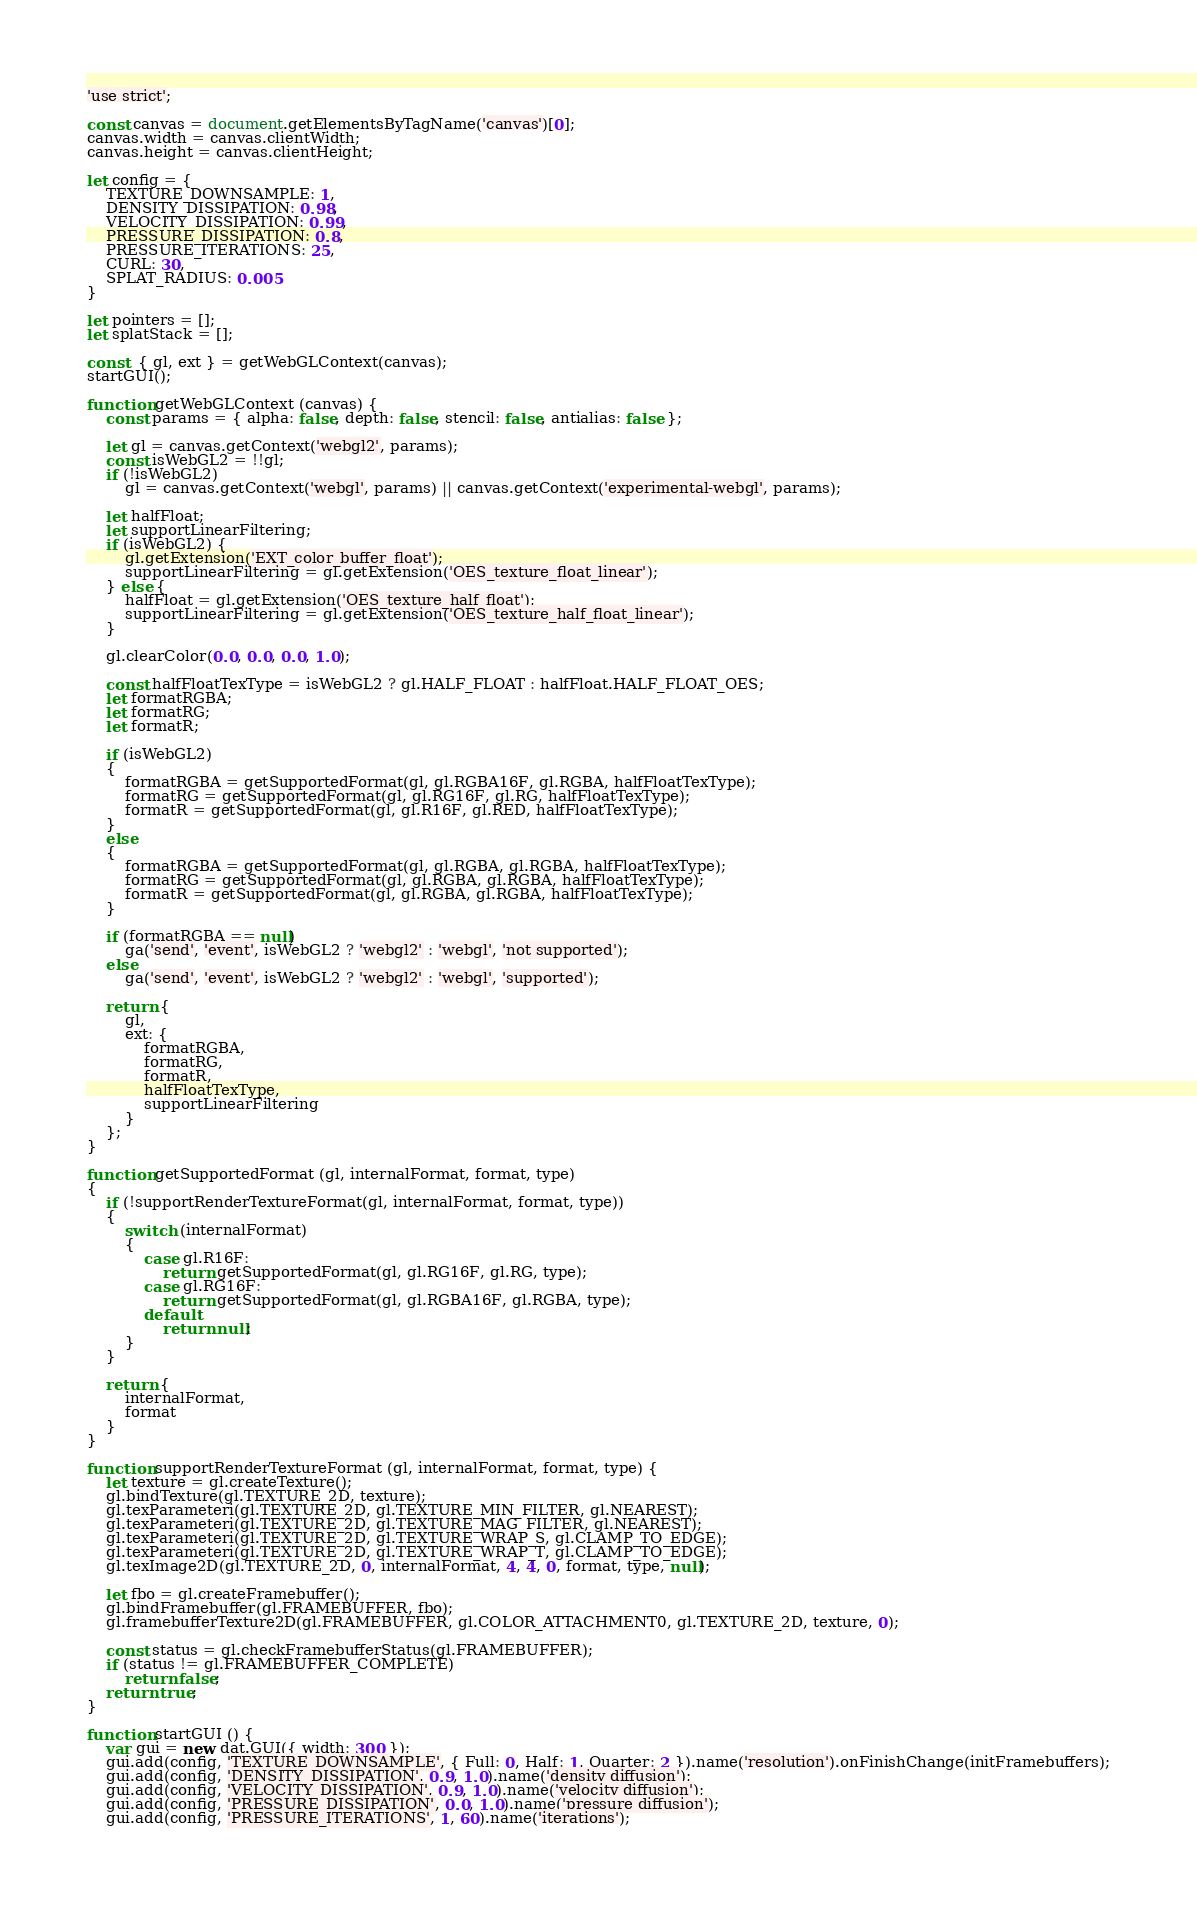<code> <loc_0><loc_0><loc_500><loc_500><_JavaScript_>'use strict';

const canvas = document.getElementsByTagName('canvas')[0];
canvas.width = canvas.clientWidth;
canvas.height = canvas.clientHeight;

let config = {
    TEXTURE_DOWNSAMPLE: 1,
    DENSITY_DISSIPATION: 0.98,
    VELOCITY_DISSIPATION: 0.99,
    PRESSURE_DISSIPATION: 0.8,
    PRESSURE_ITERATIONS: 25,
    CURL: 30,
    SPLAT_RADIUS: 0.005
}

let pointers = [];
let splatStack = [];

const  { gl, ext } = getWebGLContext(canvas);
startGUI();

function getWebGLContext (canvas) {
    const params = { alpha: false, depth: false, stencil: false, antialias: false };

    let gl = canvas.getContext('webgl2', params);
    const isWebGL2 = !!gl;
    if (!isWebGL2)
        gl = canvas.getContext('webgl', params) || canvas.getContext('experimental-webgl', params);

    let halfFloat;
    let supportLinearFiltering;
    if (isWebGL2) {
        gl.getExtension('EXT_color_buffer_float');
        supportLinearFiltering = gl.getExtension('OES_texture_float_linear');
    } else {
        halfFloat = gl.getExtension('OES_texture_half_float');
        supportLinearFiltering = gl.getExtension('OES_texture_half_float_linear');
    }

    gl.clearColor(0.0, 0.0, 0.0, 1.0);

    const halfFloatTexType = isWebGL2 ? gl.HALF_FLOAT : halfFloat.HALF_FLOAT_OES;
    let formatRGBA;
    let formatRG;
    let formatR;

    if (isWebGL2)
    {
        formatRGBA = getSupportedFormat(gl, gl.RGBA16F, gl.RGBA, halfFloatTexType);
        formatRG = getSupportedFormat(gl, gl.RG16F, gl.RG, halfFloatTexType);
        formatR = getSupportedFormat(gl, gl.R16F, gl.RED, halfFloatTexType);
    }
    else
    {
        formatRGBA = getSupportedFormat(gl, gl.RGBA, gl.RGBA, halfFloatTexType);
        formatRG = getSupportedFormat(gl, gl.RGBA, gl.RGBA, halfFloatTexType);
        formatR = getSupportedFormat(gl, gl.RGBA, gl.RGBA, halfFloatTexType);
    }

    if (formatRGBA == null)
        ga('send', 'event', isWebGL2 ? 'webgl2' : 'webgl', 'not supported');
    else
        ga('send', 'event', isWebGL2 ? 'webgl2' : 'webgl', 'supported');

    return {
        gl,
        ext: {
            formatRGBA,
            formatRG,
            formatR,
            halfFloatTexType,
            supportLinearFiltering
        }
    };
}

function getSupportedFormat (gl, internalFormat, format, type)
{
    if (!supportRenderTextureFormat(gl, internalFormat, format, type))
    {
        switch (internalFormat)
        {
            case gl.R16F:
                return getSupportedFormat(gl, gl.RG16F, gl.RG, type);
            case gl.RG16F:
                return getSupportedFormat(gl, gl.RGBA16F, gl.RGBA, type);
            default:
                return null;
        }
    }

    return {
        internalFormat,
        format
    }
}

function supportRenderTextureFormat (gl, internalFormat, format, type) {
    let texture = gl.createTexture();
    gl.bindTexture(gl.TEXTURE_2D, texture);
    gl.texParameteri(gl.TEXTURE_2D, gl.TEXTURE_MIN_FILTER, gl.NEAREST);
    gl.texParameteri(gl.TEXTURE_2D, gl.TEXTURE_MAG_FILTER, gl.NEAREST);
    gl.texParameteri(gl.TEXTURE_2D, gl.TEXTURE_WRAP_S, gl.CLAMP_TO_EDGE);
    gl.texParameteri(gl.TEXTURE_2D, gl.TEXTURE_WRAP_T, gl.CLAMP_TO_EDGE);
    gl.texImage2D(gl.TEXTURE_2D, 0, internalFormat, 4, 4, 0, format, type, null);

    let fbo = gl.createFramebuffer();
    gl.bindFramebuffer(gl.FRAMEBUFFER, fbo);
    gl.framebufferTexture2D(gl.FRAMEBUFFER, gl.COLOR_ATTACHMENT0, gl.TEXTURE_2D, texture, 0);

    const status = gl.checkFramebufferStatus(gl.FRAMEBUFFER);
    if (status != gl.FRAMEBUFFER_COMPLETE)
        return false;
    return true;
}

function startGUI () {
    var gui = new dat.GUI({ width: 300 });
    gui.add(config, 'TEXTURE_DOWNSAMPLE', { Full: 0, Half: 1, Quarter: 2 }).name('resolution').onFinishChange(initFramebuffers);
    gui.add(config, 'DENSITY_DISSIPATION', 0.9, 1.0).name('density diffusion');
    gui.add(config, 'VELOCITY_DISSIPATION', 0.9, 1.0).name('velocity diffusion');
    gui.add(config, 'PRESSURE_DISSIPATION', 0.0, 1.0).name('pressure diffusion');
    gui.add(config, 'PRESSURE_ITERATIONS', 1, 60).name('iterations');</code> 